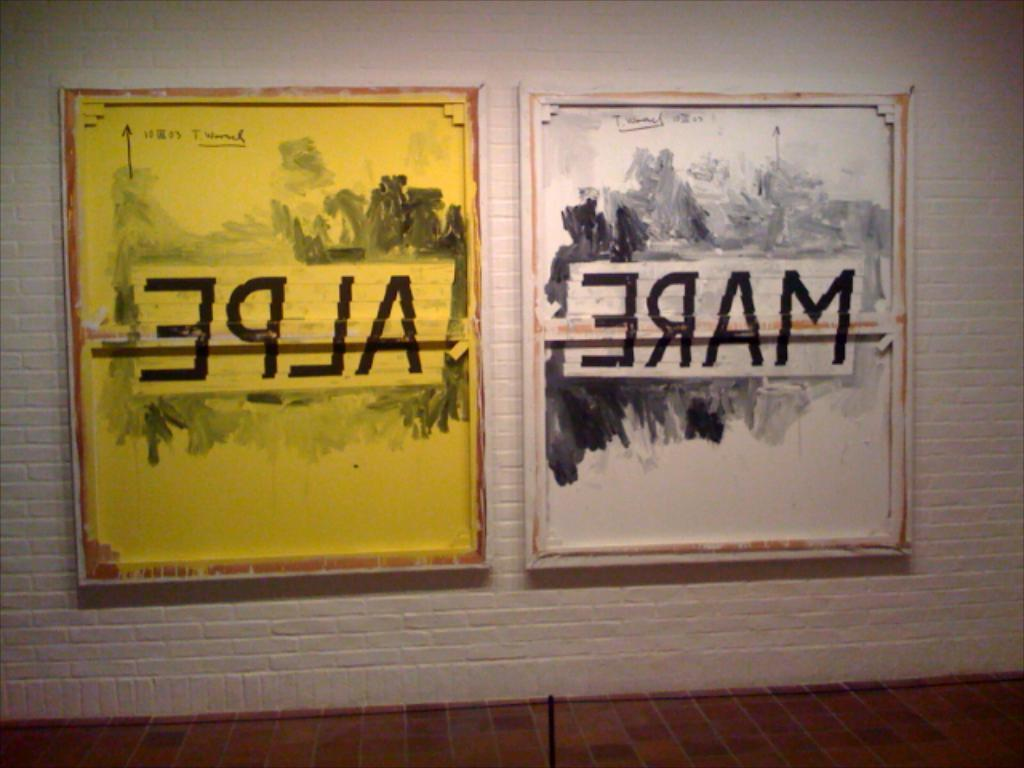Provide a one-sentence caption for the provided image. Two pictures hang on a wall with reverse writing on them. 